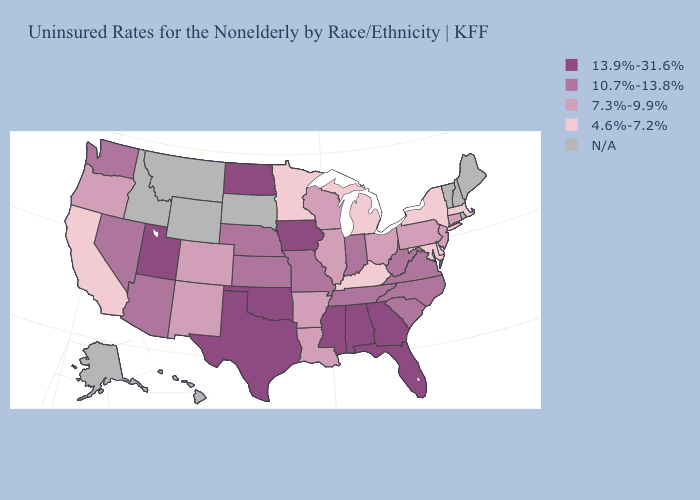Which states have the lowest value in the MidWest?
Concise answer only. Michigan, Minnesota. What is the highest value in states that border Michigan?
Answer briefly. 10.7%-13.8%. Name the states that have a value in the range 10.7%-13.8%?
Concise answer only. Arizona, Indiana, Kansas, Missouri, Nebraska, Nevada, North Carolina, South Carolina, Tennessee, Virginia, Washington, West Virginia. Among the states that border Utah , which have the lowest value?
Concise answer only. Colorado, New Mexico. What is the value of Kansas?
Give a very brief answer. 10.7%-13.8%. Among the states that border Florida , which have the lowest value?
Concise answer only. Alabama, Georgia. Name the states that have a value in the range 7.3%-9.9%?
Answer briefly. Arkansas, Colorado, Connecticut, Illinois, Louisiana, New Jersey, New Mexico, Ohio, Oregon, Pennsylvania, Wisconsin. Does Texas have the highest value in the USA?
Concise answer only. Yes. Which states hav the highest value in the Northeast?
Keep it brief. Connecticut, New Jersey, Pennsylvania. Does Missouri have the highest value in the MidWest?
Keep it brief. No. Name the states that have a value in the range 4.6%-7.2%?
Quick response, please. California, Delaware, Kentucky, Maryland, Massachusetts, Michigan, Minnesota, New York. What is the value of Pennsylvania?
Short answer required. 7.3%-9.9%. Does Colorado have the lowest value in the USA?
Concise answer only. No. What is the value of Arizona?
Concise answer only. 10.7%-13.8%. 